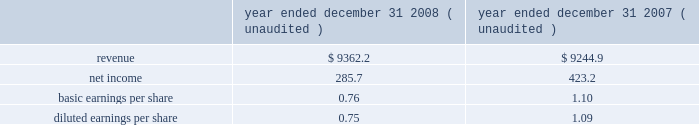The intangible assets identified that were determined to have value as a result of our analysis of allied 2019s projected revenue streams and their related profits include customer relationships , franchise agreements , other municipal agreements , non-compete agreements and trade names .
The fair values for these intangible assets are reflected in the previous table .
Other intangible assets were identified that are considered to be components of either property and equipment or goodwill under u.s .
Gaap , including the value of the permitted and probable airspace at allied 2019s landfills ( property and equipment ) , the going concern element of allied 2019s business ( goodwill ) and its assembled workforce ( goodwill ) .
The going concern element represents the ability of an established business to earn a higher rate of return on an assembled collection of net assets than would be expected if those assets had to be acquired separately .
A substantial portion of this going concern element acquired is represented by allied 2019s infrastructure of market-based collection routes and its related integrated waste transfer and disposal channels , whose value has been included in goodwill .
All of the goodwill and other intangible assets resulting from the acquisition of allied will not be deductible for income tax purposes .
Pro forma information the consolidated financial statements presented for republic include the operating results of allied from the date of the acquisition .
The following pro forma information is presented assuming the merger had been completed as of january 1 , 2007 .
The unaudited pro forma information presented has been prepared for illustrative purposes and is not intended to be indicative of the results of operations that would have actually occurred had the acquisition been consummated at the beginning of the periods presented or of future results of the combined operations .
Furthermore , the pro forma results do not give effect to all cost savings or incremental costs that occur as a result of the integration and consolidation of the acquisition ( in millions , except share and per share amounts ) .
Year ended december 31 , year ended december 31 , ( unaudited ) ( unaudited ) .
The unaudited pro forma financial information includes adjustments for amortization of identifiable intangible assets , accretion of discounts to fair value associated with debt , environmental , self-insurance and other liabilities , accretion of capping , closure and post-closure obligations and amortization of the related assets , and provision for income taxes .
Assets held for sale as a condition of the merger with allied , the department of justice ( doj ) required us to divest of certain assets and related liabilities .
As such , we classified these assets and liabilities as assets held for sale in our consolidated balance sheet at december 31 , 2008 .
Certain of the legacy republic assets classified as held for sale were adjusted to their estimated fair values less costs to sell and resulted in the recognition of an asset impairment loss of $ 1.8 million and $ 6.1 million in our consolidated statements of income for the years ended december 31 , 2009 and 2008 , respectively .
The assets held for sale related to operations that were allied 2019s were recorded at their estimated fair values in our consolidated balance sheet as of december 31 , 2008 in republic services , inc .
And subsidiaries notes to consolidated financial statements , continued .
Based on the year ended december 31 2008 ( unaudited ) information what was the net profit margin? 
Rationale: the net profit margin is the net income divide by the revenues
Computations: (285.7 / 9362.2)
Answer: 0.03052. 